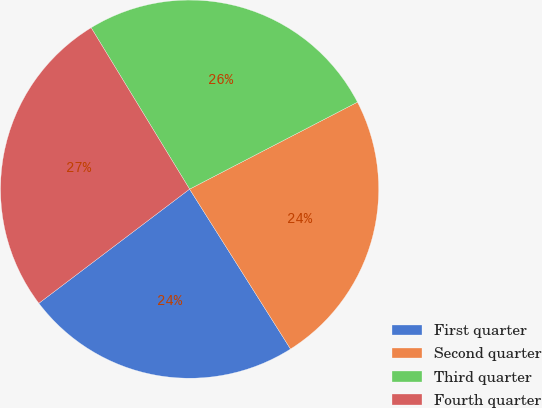Convert chart to OTSL. <chart><loc_0><loc_0><loc_500><loc_500><pie_chart><fcel>First quarter<fcel>Second quarter<fcel>Third quarter<fcel>Fourth quarter<nl><fcel>23.65%<fcel>23.65%<fcel>26.11%<fcel>26.6%<nl></chart> 